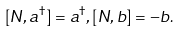<formula> <loc_0><loc_0><loc_500><loc_500>[ N , a ^ { \dagger } ] = a ^ { \dagger } , [ N , b ] = - b .</formula> 